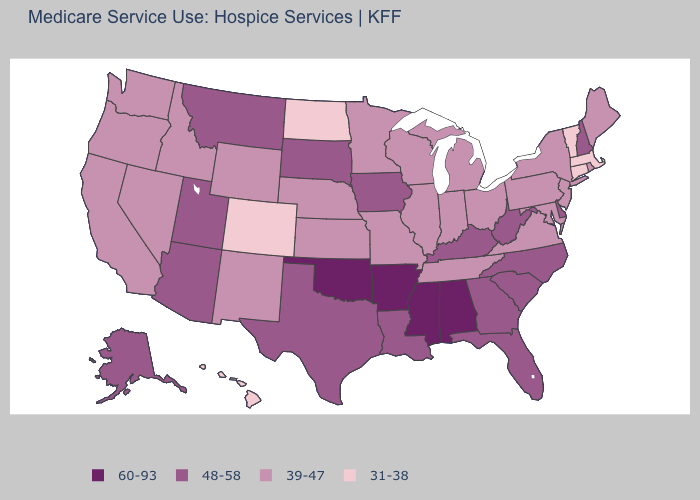Which states have the lowest value in the USA?
Answer briefly. Colorado, Connecticut, Hawaii, Massachusetts, North Dakota, Vermont. Name the states that have a value in the range 31-38?
Answer briefly. Colorado, Connecticut, Hawaii, Massachusetts, North Dakota, Vermont. Is the legend a continuous bar?
Write a very short answer. No. What is the value of Kentucky?
Quick response, please. 48-58. What is the value of Delaware?
Concise answer only. 48-58. Is the legend a continuous bar?
Quick response, please. No. Does Missouri have a higher value than Colorado?
Give a very brief answer. Yes. Name the states that have a value in the range 48-58?
Be succinct. Alaska, Arizona, Delaware, Florida, Georgia, Iowa, Kentucky, Louisiana, Montana, New Hampshire, North Carolina, South Carolina, South Dakota, Texas, Utah, West Virginia. What is the lowest value in the MidWest?
Short answer required. 31-38. What is the value of Indiana?
Concise answer only. 39-47. Does Montana have the highest value in the USA?
Quick response, please. No. What is the value of South Dakota?
Be succinct. 48-58. Does the map have missing data?
Answer briefly. No. What is the value of Alaska?
Write a very short answer. 48-58. Name the states that have a value in the range 48-58?
Give a very brief answer. Alaska, Arizona, Delaware, Florida, Georgia, Iowa, Kentucky, Louisiana, Montana, New Hampshire, North Carolina, South Carolina, South Dakota, Texas, Utah, West Virginia. 